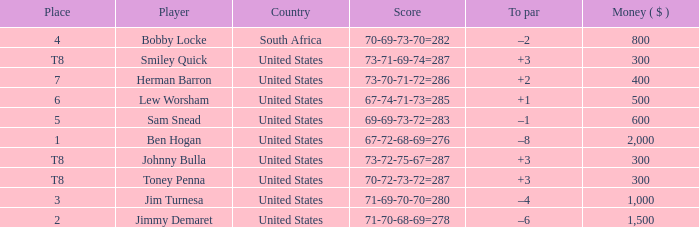What is the Money of the Player in Place 5? 600.0. 